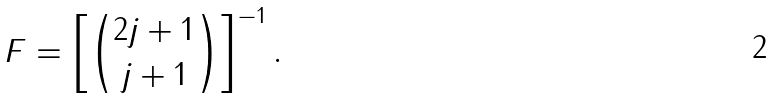<formula> <loc_0><loc_0><loc_500><loc_500>F = \left [ { 2 j + 1 \choose j + 1 } \right ] ^ { - 1 } .</formula> 